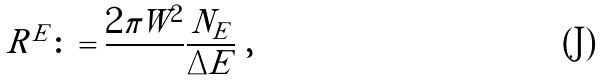Convert formula to latex. <formula><loc_0><loc_0><loc_500><loc_500>R ^ { E } \colon = \frac { 2 \pi W ^ { 2 } } { } \frac { N _ { E } } { \Delta E } \ ,</formula> 